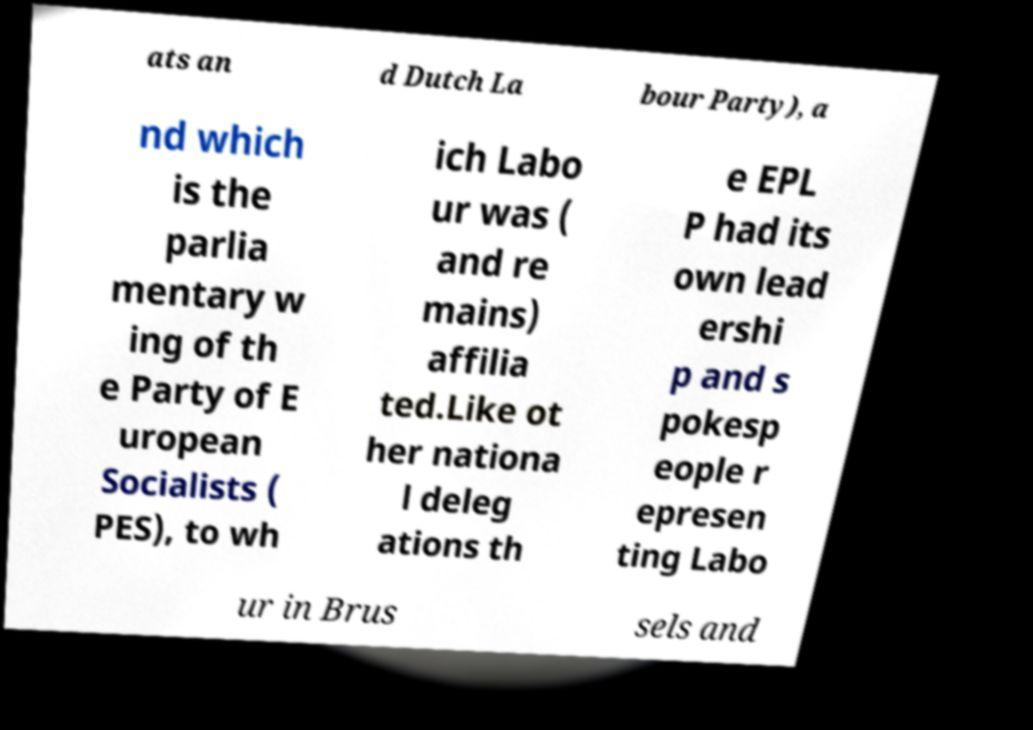Please read and relay the text visible in this image. What does it say? ats an d Dutch La bour Party), a nd which is the parlia mentary w ing of th e Party of E uropean Socialists ( PES), to wh ich Labo ur was ( and re mains) affilia ted.Like ot her nationa l deleg ations th e EPL P had its own lead ershi p and s pokesp eople r epresen ting Labo ur in Brus sels and 